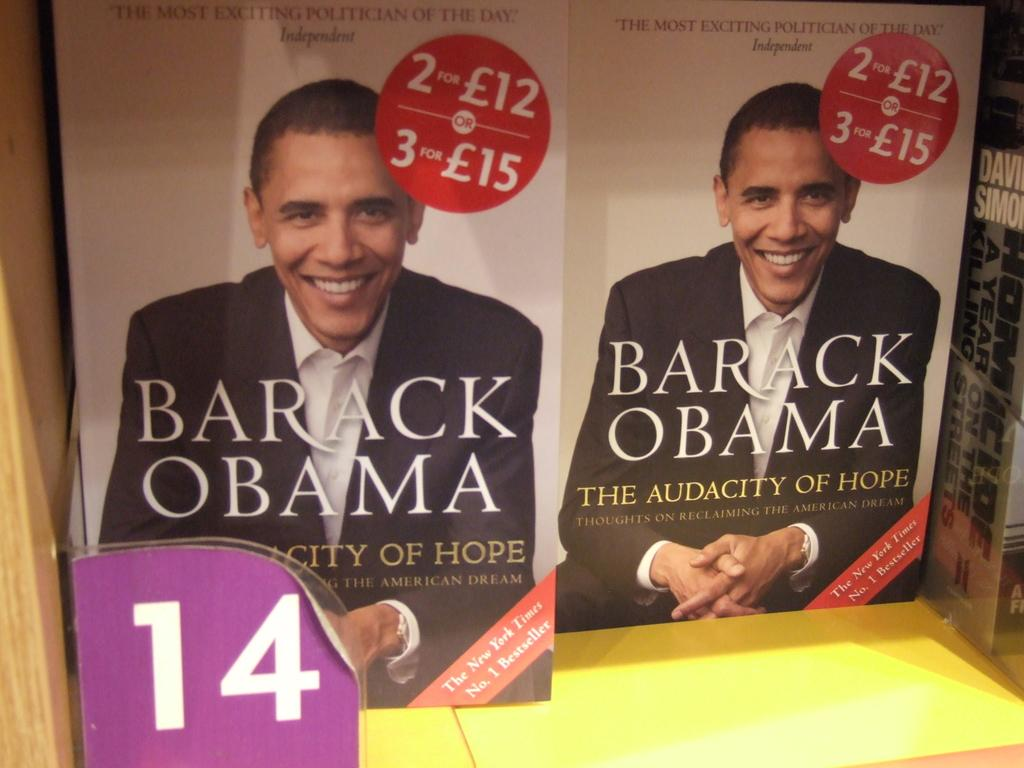<image>
Share a concise interpretation of the image provided. Two books on a bookshelf titled "The Audacity of Hope" written by Barack Obama 